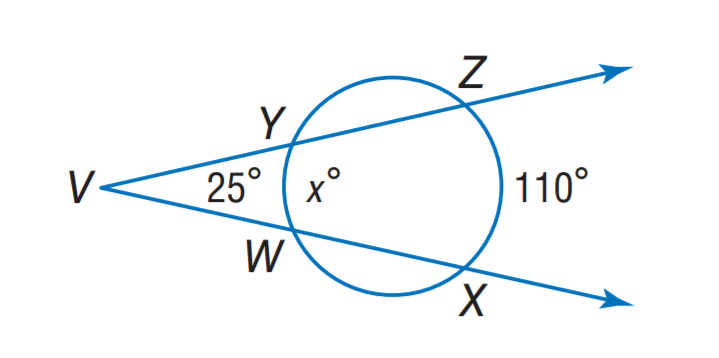Question: Find x.
Choices:
A. 50
B. 55
C. 60
D. 70
Answer with the letter. Answer: C 